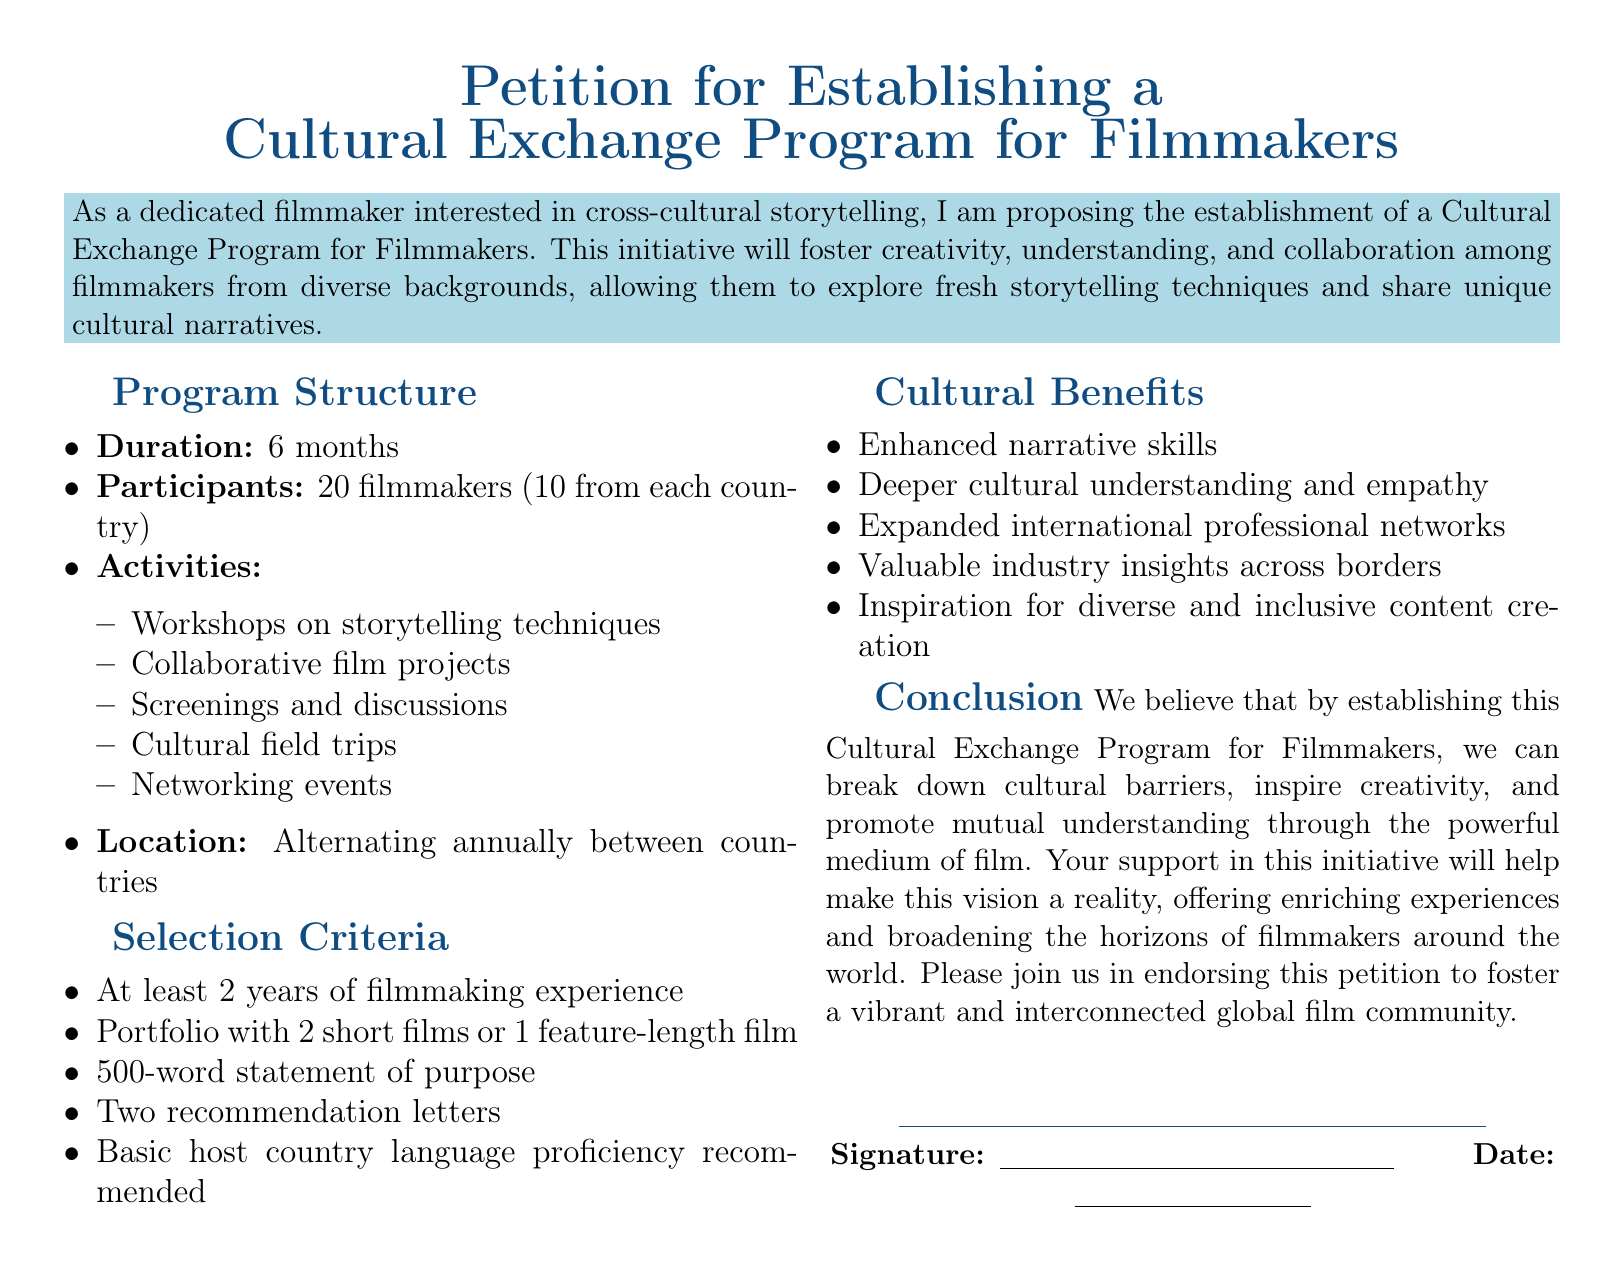What is the duration of the program? The duration is specified in the document as 6 months.
Answer: 6 months How many filmmakers will participate? The document states that 20 filmmakers will participate in the program.
Answer: 20 filmmakers What are the recommended language skills? The document mentions basic host country language proficiency is recommended.
Answer: Basic host country language proficiency What is included in the activities of the program? The document lists workshops on storytelling techniques among other activities.
Answer: Workshops on storytelling techniques What are the selection criteria related to experience? The document specifies that participants must have at least 2 years of filmmaking experience.
Answer: At least 2 years How many short films are required in the portfolio? The document states that the portfolio should contain 2 short films or 1 feature-length film.
Answer: 2 short films What is one anticipated cultural benefit? The document lists enhanced narrative skills as one of the cultural benefits.
Answer: Enhanced narrative skills What is the location arrangement for the program? The program location alternates annually between countries as stated in the document.
Answer: Alternating annually between countries What is the purpose of the statement required from applicants? The document specifies a 500-word statement of purpose is required for applicants.
Answer: 500-word statement of purpose 